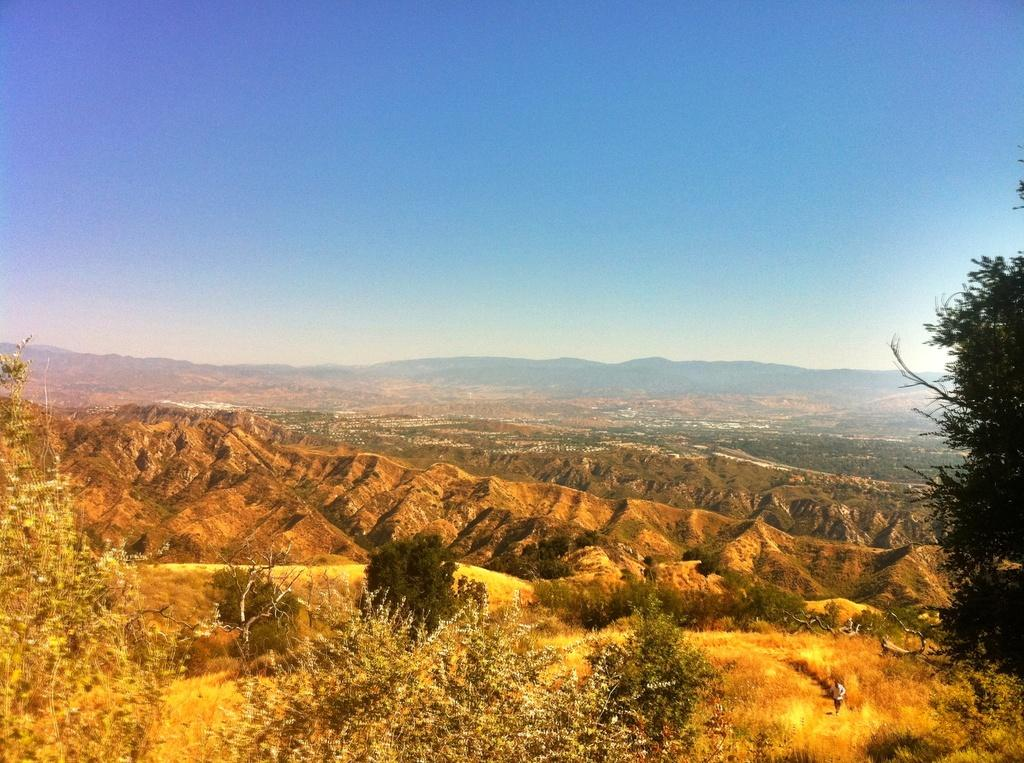What type of vegetation can be seen in the image? There are trees and plants in the image. What type of landscape feature is present in the image? There are hills in the image. What part of the natural environment is visible in the image? The sky is visible in the image. What type of silverware is being used for lunch in the image? There is no silverware or lunch present in the image; it features trees, plants, hills, and the sky. 